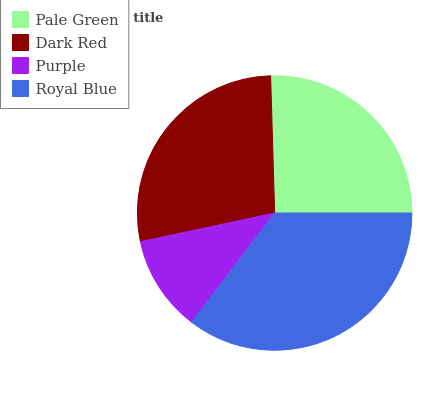Is Purple the minimum?
Answer yes or no. Yes. Is Royal Blue the maximum?
Answer yes or no. Yes. Is Dark Red the minimum?
Answer yes or no. No. Is Dark Red the maximum?
Answer yes or no. No. Is Dark Red greater than Pale Green?
Answer yes or no. Yes. Is Pale Green less than Dark Red?
Answer yes or no. Yes. Is Pale Green greater than Dark Red?
Answer yes or no. No. Is Dark Red less than Pale Green?
Answer yes or no. No. Is Dark Red the high median?
Answer yes or no. Yes. Is Pale Green the low median?
Answer yes or no. Yes. Is Purple the high median?
Answer yes or no. No. Is Dark Red the low median?
Answer yes or no. No. 